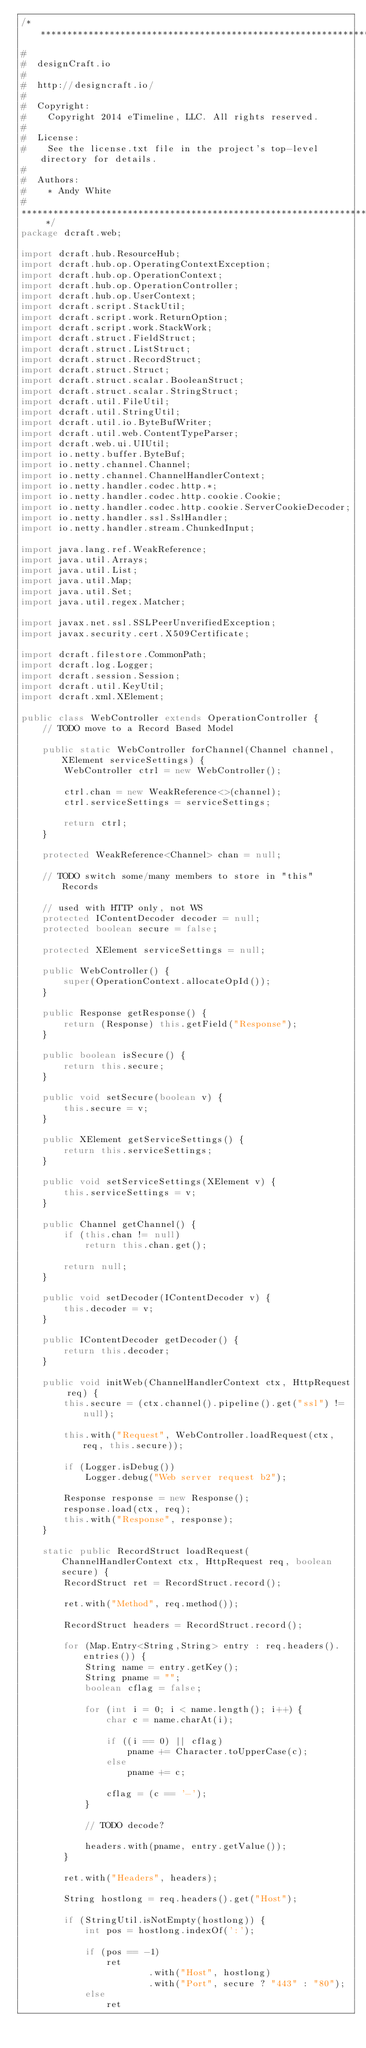Convert code to text. <code><loc_0><loc_0><loc_500><loc_500><_Java_>/* ************************************************************************
#
#  designCraft.io
#
#  http://designcraft.io/
#
#  Copyright:
#    Copyright 2014 eTimeline, LLC. All rights reserved.
#
#  License:
#    See the license.txt file in the project's top-level directory for details.
#
#  Authors:
#    * Andy White
#
************************************************************************ */
package dcraft.web;

import dcraft.hub.ResourceHub;
import dcraft.hub.op.OperatingContextException;
import dcraft.hub.op.OperationContext;
import dcraft.hub.op.OperationController;
import dcraft.hub.op.UserContext;
import dcraft.script.StackUtil;
import dcraft.script.work.ReturnOption;
import dcraft.script.work.StackWork;
import dcraft.struct.FieldStruct;
import dcraft.struct.ListStruct;
import dcraft.struct.RecordStruct;
import dcraft.struct.Struct;
import dcraft.struct.scalar.BooleanStruct;
import dcraft.struct.scalar.StringStruct;
import dcraft.util.FileUtil;
import dcraft.util.StringUtil;
import dcraft.util.io.ByteBufWriter;
import dcraft.util.web.ContentTypeParser;
import dcraft.web.ui.UIUtil;
import io.netty.buffer.ByteBuf;
import io.netty.channel.Channel;
import io.netty.channel.ChannelHandlerContext;
import io.netty.handler.codec.http.*;
import io.netty.handler.codec.http.cookie.Cookie;
import io.netty.handler.codec.http.cookie.ServerCookieDecoder;
import io.netty.handler.ssl.SslHandler;
import io.netty.handler.stream.ChunkedInput;

import java.lang.ref.WeakReference;
import java.util.Arrays;
import java.util.List;
import java.util.Map;
import java.util.Set;
import java.util.regex.Matcher;

import javax.net.ssl.SSLPeerUnverifiedException;
import javax.security.cert.X509Certificate;

import dcraft.filestore.CommonPath;
import dcraft.log.Logger;
import dcraft.session.Session;
import dcraft.util.KeyUtil;
import dcraft.xml.XElement;

public class WebController extends OperationController {
	// TODO move to a Record Based Model

	public static WebController forChannel(Channel channel, XElement serviceSettings) {
		WebController ctrl = new WebController();
		
		ctrl.chan = new WeakReference<>(channel);
		ctrl.serviceSettings = serviceSettings;
		
		return ctrl;
	}
	
	protected WeakReference<Channel> chan = null;

	// TODO switch some/many members to store in "this" Records

    // used with HTTP only, not WS
	protected IContentDecoder decoder = null;    	
    protected boolean secure = false;
    
    protected XElement serviceSettings = null;

	public WebController() {
		super(OperationContext.allocateOpId());
	}
    
    public Response getResponse() {
		return (Response) this.getField("Response");
	}
	
	public boolean isSecure() {
		return this.secure;
	}
	
	public void setSecure(boolean v) {
		this.secure = v;
	}
	
	public XElement getServiceSettings() {
		return this.serviceSettings;
	}
	
	public void setServiceSettings(XElement v) {
		this.serviceSettings = v;
	}
	
	public Channel getChannel() {
		if (this.chan != null)
			return this.chan.get();
		
		return null;
	}
	
    public void setDecoder(IContentDecoder v) {
		this.decoder = v;
	}
    
    public IContentDecoder getDecoder() {
		return this.decoder;
	}
    
	public void initWeb(ChannelHandlerContext ctx, HttpRequest req) {
		this.secure = (ctx.channel().pipeline().get("ssl") != null);

        this.with("Request", WebController.loadRequest(ctx, req, this.secure));

		if (Logger.isDebug())
			Logger.debug("Web server request b2");

		Response response = new Response();
        response.load(ctx, req);
    	this.with("Response", response);
	}
	
	static public RecordStruct loadRequest(ChannelHandlerContext ctx, HttpRequest req, boolean secure) {
		RecordStruct ret = RecordStruct.record();
		
		ret.with("Method", req.method());
		
		RecordStruct headers = RecordStruct.record();
		
		for (Map.Entry<String,String> entry : req.headers().entries()) {
			String name = entry.getKey();
			String pname = "";
			boolean cflag = false;

			for (int i = 0; i < name.length(); i++) {
				char c = name.charAt(i);

				if ((i == 0) || cflag)
					pname += Character.toUpperCase(c);
				else
					pname += c;

				cflag = (c == '-');
			}

			// TODO decode?

			headers.with(pname, entry.getValue());
		}
		
		ret.with("Headers", headers);
		
		String hostlong = req.headers().get("Host");
		
		if (StringUtil.isNotEmpty(hostlong)) {
			int pos = hostlong.indexOf(':');

			if (pos == -1)
				ret
						.with("Host", hostlong)
						.with("Port", secure ? "443" : "80");
			else
				ret</code> 